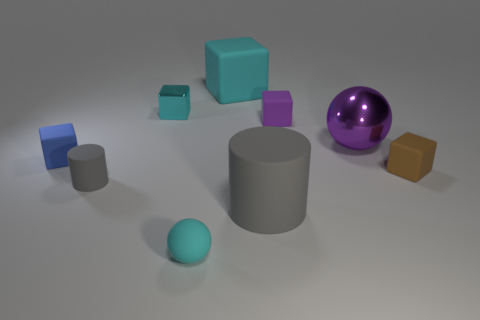Which objects in the scene are closest to the camera? The objects closest to the camera are the light blue sphere in the foreground, followed by the grey cylinder to its right. The brown cube and the purple glossy ball are slightly behind, making them the next closest in this arrangement. 